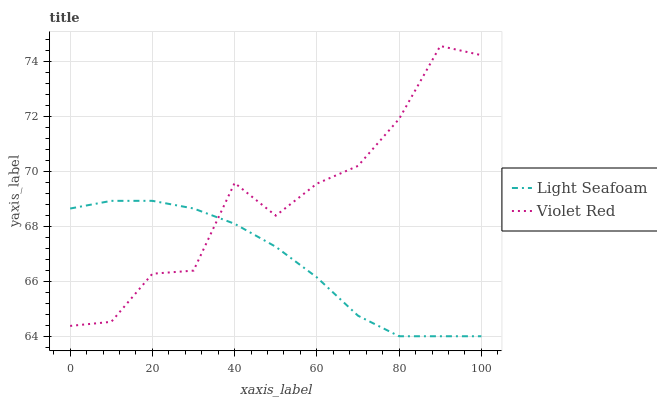Does Light Seafoam have the minimum area under the curve?
Answer yes or no. Yes. Does Violet Red have the maximum area under the curve?
Answer yes or no. Yes. Does Light Seafoam have the maximum area under the curve?
Answer yes or no. No. Is Light Seafoam the smoothest?
Answer yes or no. Yes. Is Violet Red the roughest?
Answer yes or no. Yes. Is Light Seafoam the roughest?
Answer yes or no. No. Does Light Seafoam have the lowest value?
Answer yes or no. Yes. Does Violet Red have the highest value?
Answer yes or no. Yes. Does Light Seafoam have the highest value?
Answer yes or no. No. Does Violet Red intersect Light Seafoam?
Answer yes or no. Yes. Is Violet Red less than Light Seafoam?
Answer yes or no. No. Is Violet Red greater than Light Seafoam?
Answer yes or no. No. 